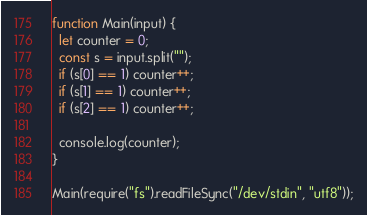Convert code to text. <code><loc_0><loc_0><loc_500><loc_500><_JavaScript_>function Main(input) {
  let counter = 0;
  const s = input.split("");
  if (s[0] == 1) counter++;
  if (s[1] == 1) counter++;
  if (s[2] == 1) counter++;

  console.log(counter);
}

Main(require("fs").readFileSync("/dev/stdin", "utf8"));
</code> 